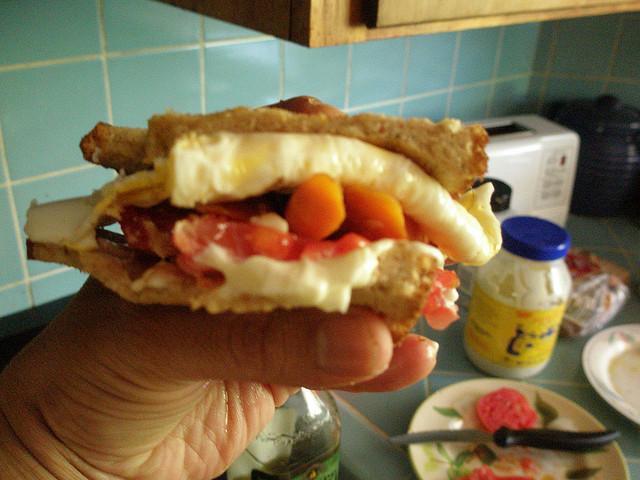How many bottles are visible?
Give a very brief answer. 2. 